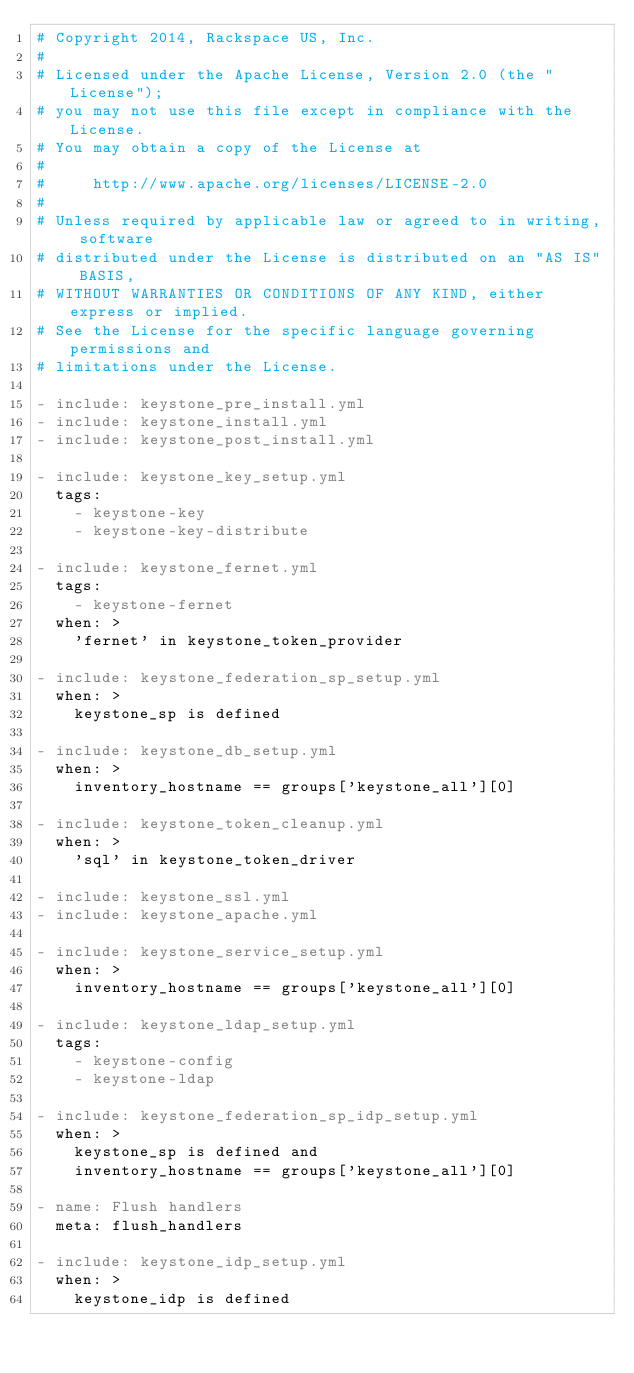Convert code to text. <code><loc_0><loc_0><loc_500><loc_500><_YAML_># Copyright 2014, Rackspace US, Inc.
#
# Licensed under the Apache License, Version 2.0 (the "License");
# you may not use this file except in compliance with the License.
# You may obtain a copy of the License at
#
#     http://www.apache.org/licenses/LICENSE-2.0
#
# Unless required by applicable law or agreed to in writing, software
# distributed under the License is distributed on an "AS IS" BASIS,
# WITHOUT WARRANTIES OR CONDITIONS OF ANY KIND, either express or implied.
# See the License for the specific language governing permissions and
# limitations under the License.

- include: keystone_pre_install.yml
- include: keystone_install.yml
- include: keystone_post_install.yml

- include: keystone_key_setup.yml
  tags:
    - keystone-key
    - keystone-key-distribute

- include: keystone_fernet.yml
  tags:
    - keystone-fernet
  when: >
    'fernet' in keystone_token_provider

- include: keystone_federation_sp_setup.yml
  when: >
    keystone_sp is defined

- include: keystone_db_setup.yml
  when: >
    inventory_hostname == groups['keystone_all'][0]

- include: keystone_token_cleanup.yml
  when: >
    'sql' in keystone_token_driver

- include: keystone_ssl.yml
- include: keystone_apache.yml

- include: keystone_service_setup.yml
  when: >
    inventory_hostname == groups['keystone_all'][0]

- include: keystone_ldap_setup.yml
  tags:
    - keystone-config
    - keystone-ldap

- include: keystone_federation_sp_idp_setup.yml
  when: >
    keystone_sp is defined and
    inventory_hostname == groups['keystone_all'][0]

- name: Flush handlers
  meta: flush_handlers

- include: keystone_idp_setup.yml
  when: >
    keystone_idp is defined
</code> 